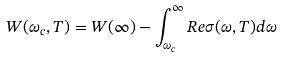<formula> <loc_0><loc_0><loc_500><loc_500>W ( \omega _ { c } , T ) = W ( \infty ) - \int _ { \omega _ { c } } ^ { \infty } R e \sigma ( \omega , T ) d \omega</formula> 